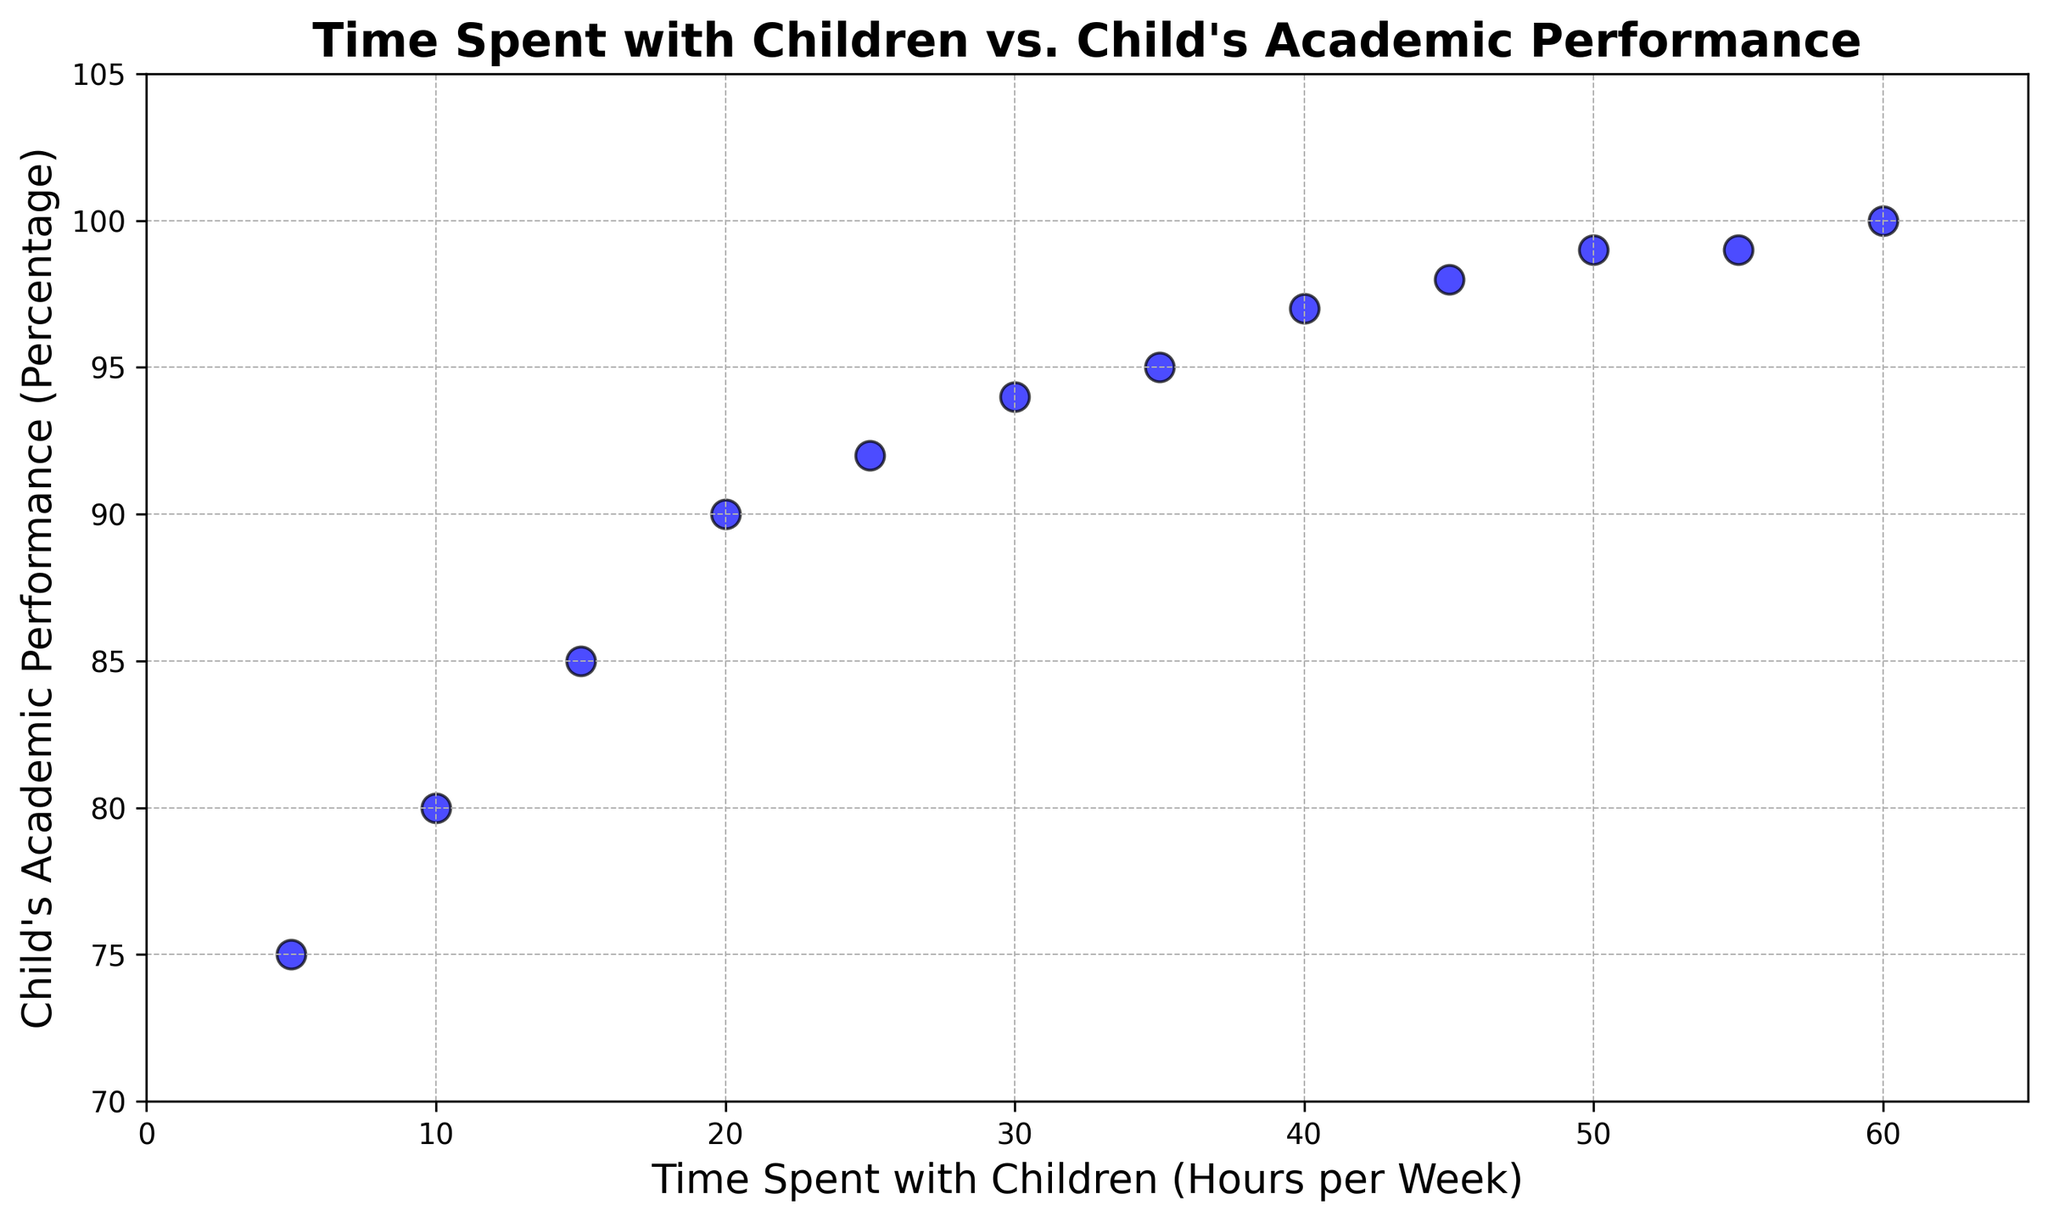What's the range of Child's Academic Performance percentages? The range is calculated by subtracting the smallest value from the largest value. Here, the minimum performance percentage is 75%, and the maximum is 100%. Therefore, the range is 100 - 75.
Answer: 25% How does Child Performance change as Parent Time increases from 10 to 20 hours per week? Examine the data points for Parent Time at 10 hours (Child Performance: 80%) and 20 hours (Child Performance: 90%). The Child Performance increases from 80% to 90%.
Answer: Increases by 10% What is the average Child's Academic Performance for Parent Time between 30 and 50 hours per week? Average is calculated by summing the Child Performance values and dividing by the number of values. For 30, 35, 40, 45, and 50 hours, performances are 94, 95, 97, 98, and 99. Sum = 94 + 95 + 97 + 98 + 99 = 483. Number of values = 5. So, average = 483 / 5.
Answer: 96.6% Is there any point where increasing Parent Time does not significantly improve Child's Academic Performance? Looking at the scatter plot, compare the Child Performance values between 50 and 60 hours. From 50 (99%) to 55 (99%) and 60 hours (100%), there is little or no improvement.
Answer: Yes, between 50 and 60 hours What trend do you observe between the Time Spent with Children and Child's Academic Performance? Observing the overall scatter plot, as the Parent Time increases, the Child Performance generally increases as well, showing a positive correlation.
Answer: Positive correlation What is the percentage increase in Child's Academic Performance when Parent Time rises from 25 to 35 hours per week? Calculate the initial performance (25 hours: 92%) and the final performance (35 hours: 95%). The percentage increase is ((95 - 92) / 92) * 100.
Answer: 3.26% At what Parent Time is the Child's Academic Performance first reaching 90%? Search for the data point where Child Performance first equals or exceeds 90%. It occurs at Parent Time of 20 hours.
Answer: 20 hours How many data points show a Child's Academic Performance of 95% or more? Count the number of data points that have Child Performance values 95% or higher. These occur at 35, 40, 45, 50, 55, and 60 hours.
Answer: 6 data points Which time interval shows the steepest increase in Child's Academic Performance? Examine the difference in Child Performance between successive intervals. The steepest increase happens where the difference is greatest within a small interval, which is 10 to 20 hours (from 80% to 90%).
Answer: 10 to 20 hours By how much does Child's Academic Performance increase on average for every 10 hours increase in Parent Time? Calculate the overall increase in Child Performance (100% - 75% = 25%) and divide by the number of 10-hour intervals (60 hours / 10 hours per interval = 6). Average increase = 25% / 6.
Answer: Approximately 4.17% 